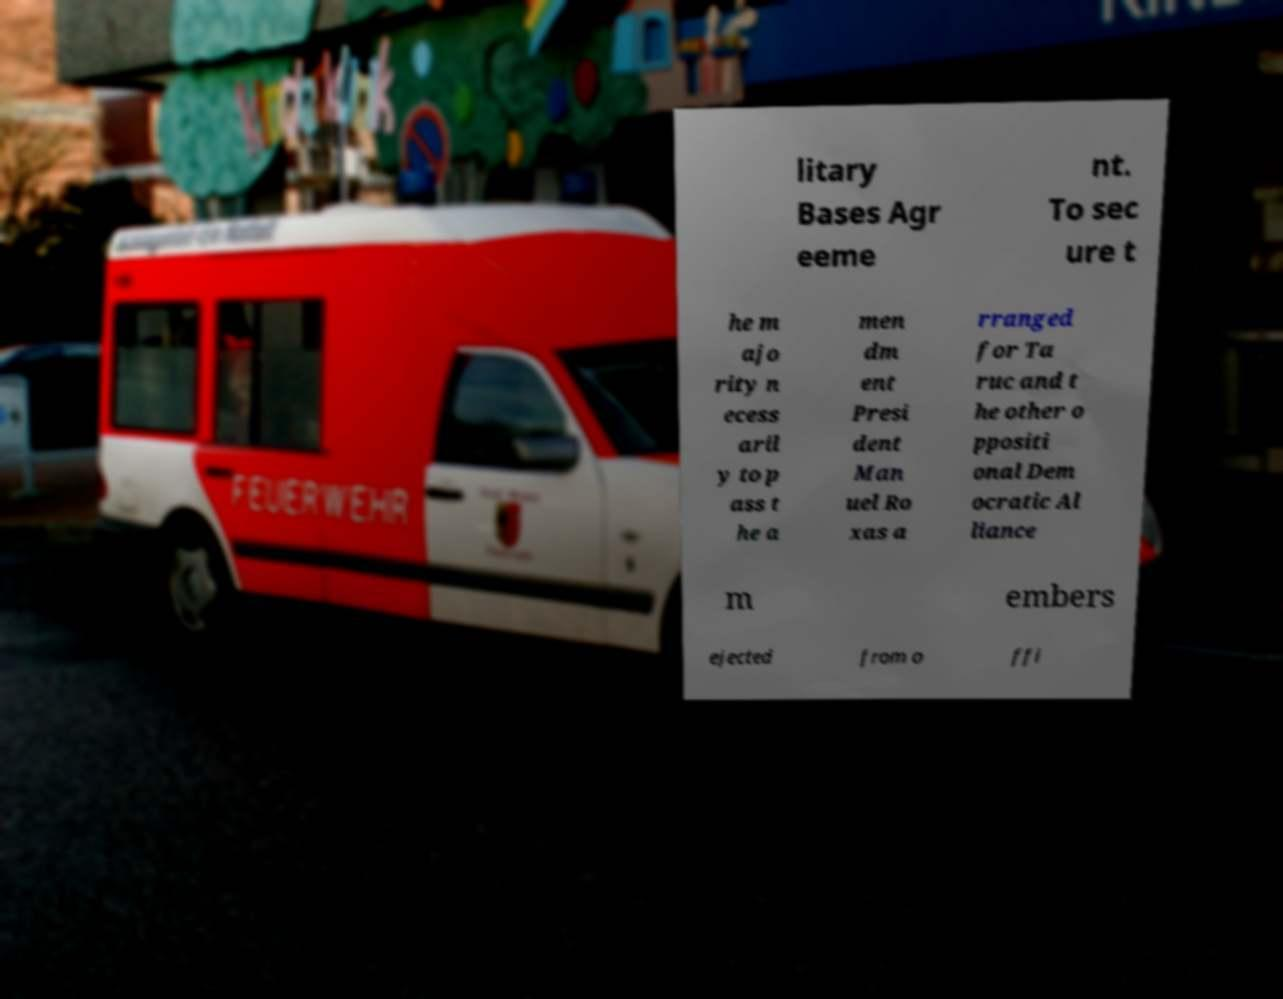I need the written content from this picture converted into text. Can you do that? litary Bases Agr eeme nt. To sec ure t he m ajo rity n ecess aril y to p ass t he a men dm ent Presi dent Man uel Ro xas a rranged for Ta ruc and t he other o ppositi onal Dem ocratic Al liance m embers ejected from o ffi 